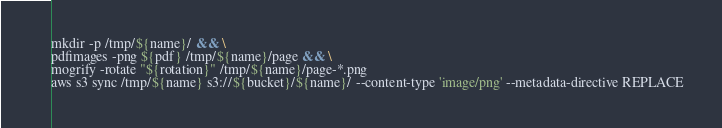Convert code to text. <code><loc_0><loc_0><loc_500><loc_500><_Bash_>mkdir -p /tmp/${name}/ && \
pdfimages -png ${pdf} /tmp/${name}/page && \
mogrify -rotate "${rotation}" /tmp/${name}/page-*.png
aws s3 sync /tmp/${name} s3://${bucket}/${name}/ --content-type 'image/png' --metadata-directive REPLACE
</code> 